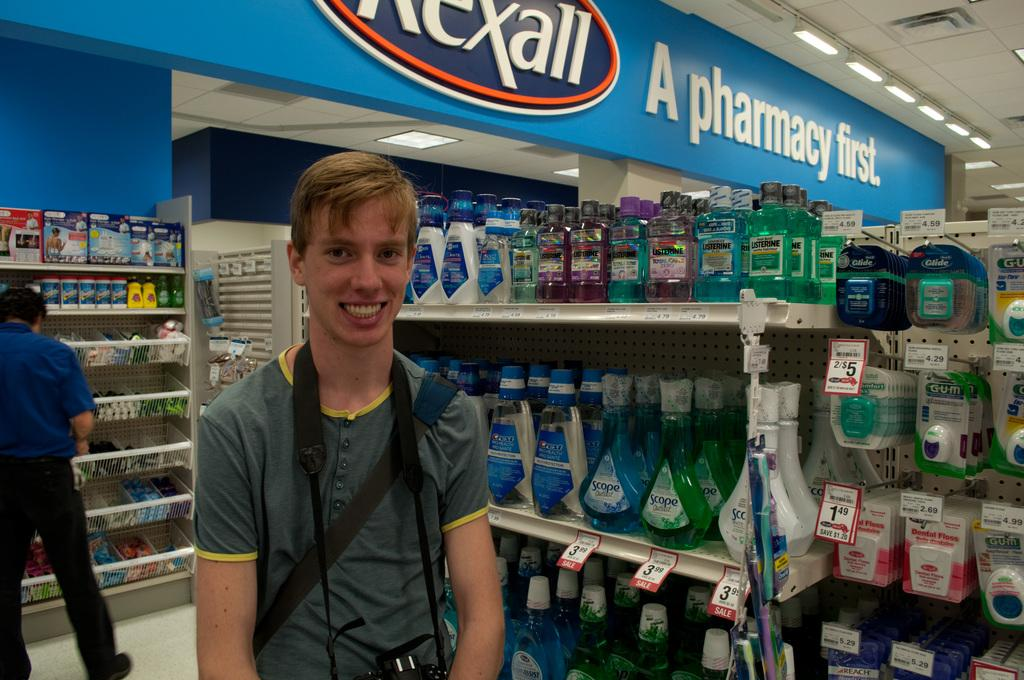<image>
Summarize the visual content of the image. A young man stands grinning at the camera in front of shelves of mouth wash in a pharmacy. 